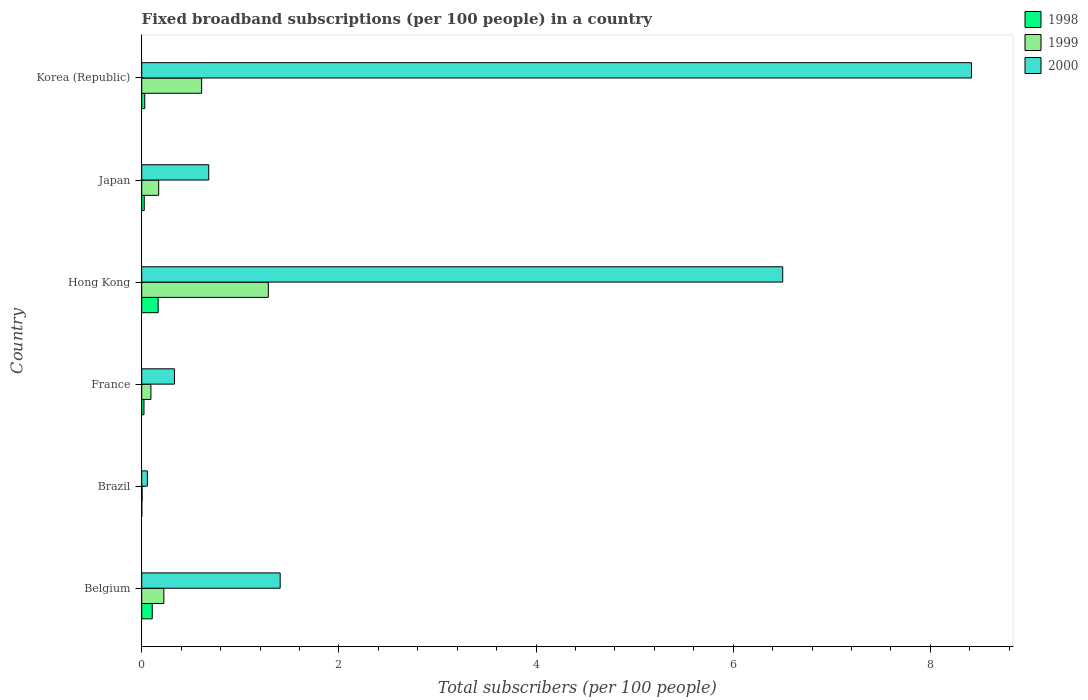How many different coloured bars are there?
Offer a very short reply. 3. How many groups of bars are there?
Offer a very short reply. 6. How many bars are there on the 2nd tick from the top?
Offer a terse response. 3. How many bars are there on the 4th tick from the bottom?
Provide a short and direct response. 3. What is the label of the 5th group of bars from the top?
Offer a very short reply. Brazil. In how many cases, is the number of bars for a given country not equal to the number of legend labels?
Your response must be concise. 0. What is the number of broadband subscriptions in 1999 in France?
Provide a succinct answer. 0.09. Across all countries, what is the maximum number of broadband subscriptions in 2000?
Your response must be concise. 8.42. Across all countries, what is the minimum number of broadband subscriptions in 1999?
Ensure brevity in your answer.  0. In which country was the number of broadband subscriptions in 1998 minimum?
Give a very brief answer. Brazil. What is the total number of broadband subscriptions in 2000 in the graph?
Give a very brief answer. 17.39. What is the difference between the number of broadband subscriptions in 2000 in Hong Kong and that in Japan?
Make the answer very short. 5.82. What is the difference between the number of broadband subscriptions in 2000 in Japan and the number of broadband subscriptions in 1999 in Hong Kong?
Your response must be concise. -0.6. What is the average number of broadband subscriptions in 2000 per country?
Your response must be concise. 2.9. What is the difference between the number of broadband subscriptions in 1999 and number of broadband subscriptions in 1998 in Japan?
Keep it short and to the point. 0.15. What is the ratio of the number of broadband subscriptions in 1999 in Brazil to that in Hong Kong?
Your answer should be very brief. 0. Is the difference between the number of broadband subscriptions in 1999 in Hong Kong and Korea (Republic) greater than the difference between the number of broadband subscriptions in 1998 in Hong Kong and Korea (Republic)?
Your response must be concise. Yes. What is the difference between the highest and the second highest number of broadband subscriptions in 1999?
Offer a terse response. 0.68. What is the difference between the highest and the lowest number of broadband subscriptions in 1998?
Your answer should be compact. 0.17. In how many countries, is the number of broadband subscriptions in 2000 greater than the average number of broadband subscriptions in 2000 taken over all countries?
Offer a very short reply. 2. Is the sum of the number of broadband subscriptions in 1998 in Hong Kong and Japan greater than the maximum number of broadband subscriptions in 1999 across all countries?
Make the answer very short. No. What does the 3rd bar from the top in Hong Kong represents?
Your answer should be very brief. 1998. Is it the case that in every country, the sum of the number of broadband subscriptions in 1998 and number of broadband subscriptions in 1999 is greater than the number of broadband subscriptions in 2000?
Ensure brevity in your answer.  No. How many bars are there?
Give a very brief answer. 18. Are all the bars in the graph horizontal?
Ensure brevity in your answer.  Yes. What is the difference between two consecutive major ticks on the X-axis?
Ensure brevity in your answer.  2. Does the graph contain any zero values?
Give a very brief answer. No. Does the graph contain grids?
Ensure brevity in your answer.  No. Where does the legend appear in the graph?
Your response must be concise. Top right. How many legend labels are there?
Keep it short and to the point. 3. How are the legend labels stacked?
Give a very brief answer. Vertical. What is the title of the graph?
Offer a terse response. Fixed broadband subscriptions (per 100 people) in a country. Does "2013" appear as one of the legend labels in the graph?
Provide a succinct answer. No. What is the label or title of the X-axis?
Provide a short and direct response. Total subscribers (per 100 people). What is the label or title of the Y-axis?
Your answer should be very brief. Country. What is the Total subscribers (per 100 people) of 1998 in Belgium?
Your response must be concise. 0.11. What is the Total subscribers (per 100 people) in 1999 in Belgium?
Keep it short and to the point. 0.22. What is the Total subscribers (per 100 people) of 2000 in Belgium?
Give a very brief answer. 1.4. What is the Total subscribers (per 100 people) in 1998 in Brazil?
Your response must be concise. 0. What is the Total subscribers (per 100 people) in 1999 in Brazil?
Make the answer very short. 0. What is the Total subscribers (per 100 people) of 2000 in Brazil?
Give a very brief answer. 0.06. What is the Total subscribers (per 100 people) of 1998 in France?
Provide a succinct answer. 0.02. What is the Total subscribers (per 100 people) in 1999 in France?
Keep it short and to the point. 0.09. What is the Total subscribers (per 100 people) in 2000 in France?
Offer a very short reply. 0.33. What is the Total subscribers (per 100 people) of 1998 in Hong Kong?
Your answer should be very brief. 0.17. What is the Total subscribers (per 100 people) in 1999 in Hong Kong?
Give a very brief answer. 1.28. What is the Total subscribers (per 100 people) in 2000 in Hong Kong?
Offer a terse response. 6.5. What is the Total subscribers (per 100 people) of 1998 in Japan?
Provide a succinct answer. 0.03. What is the Total subscribers (per 100 people) in 1999 in Japan?
Your answer should be very brief. 0.17. What is the Total subscribers (per 100 people) of 2000 in Japan?
Keep it short and to the point. 0.68. What is the Total subscribers (per 100 people) in 1998 in Korea (Republic)?
Ensure brevity in your answer.  0.03. What is the Total subscribers (per 100 people) in 1999 in Korea (Republic)?
Keep it short and to the point. 0.61. What is the Total subscribers (per 100 people) of 2000 in Korea (Republic)?
Ensure brevity in your answer.  8.42. Across all countries, what is the maximum Total subscribers (per 100 people) of 1998?
Your answer should be very brief. 0.17. Across all countries, what is the maximum Total subscribers (per 100 people) of 1999?
Provide a succinct answer. 1.28. Across all countries, what is the maximum Total subscribers (per 100 people) of 2000?
Offer a very short reply. 8.42. Across all countries, what is the minimum Total subscribers (per 100 people) in 1998?
Offer a very short reply. 0. Across all countries, what is the minimum Total subscribers (per 100 people) of 1999?
Offer a terse response. 0. Across all countries, what is the minimum Total subscribers (per 100 people) in 2000?
Make the answer very short. 0.06. What is the total Total subscribers (per 100 people) of 1998 in the graph?
Provide a succinct answer. 0.35. What is the total Total subscribers (per 100 people) in 1999 in the graph?
Offer a very short reply. 2.39. What is the total Total subscribers (per 100 people) of 2000 in the graph?
Provide a succinct answer. 17.39. What is the difference between the Total subscribers (per 100 people) in 1998 in Belgium and that in Brazil?
Make the answer very short. 0.11. What is the difference between the Total subscribers (per 100 people) in 1999 in Belgium and that in Brazil?
Keep it short and to the point. 0.22. What is the difference between the Total subscribers (per 100 people) in 2000 in Belgium and that in Brazil?
Keep it short and to the point. 1.35. What is the difference between the Total subscribers (per 100 people) of 1998 in Belgium and that in France?
Make the answer very short. 0.08. What is the difference between the Total subscribers (per 100 people) in 1999 in Belgium and that in France?
Your answer should be compact. 0.13. What is the difference between the Total subscribers (per 100 people) of 2000 in Belgium and that in France?
Your response must be concise. 1.07. What is the difference between the Total subscribers (per 100 people) of 1998 in Belgium and that in Hong Kong?
Keep it short and to the point. -0.06. What is the difference between the Total subscribers (per 100 people) in 1999 in Belgium and that in Hong Kong?
Offer a terse response. -1.06. What is the difference between the Total subscribers (per 100 people) of 2000 in Belgium and that in Hong Kong?
Your answer should be compact. -5.1. What is the difference between the Total subscribers (per 100 people) of 1998 in Belgium and that in Japan?
Provide a short and direct response. 0.08. What is the difference between the Total subscribers (per 100 people) in 1999 in Belgium and that in Japan?
Make the answer very short. 0.05. What is the difference between the Total subscribers (per 100 people) in 2000 in Belgium and that in Japan?
Give a very brief answer. 0.72. What is the difference between the Total subscribers (per 100 people) in 1998 in Belgium and that in Korea (Republic)?
Your response must be concise. 0.08. What is the difference between the Total subscribers (per 100 people) in 1999 in Belgium and that in Korea (Republic)?
Offer a terse response. -0.38. What is the difference between the Total subscribers (per 100 people) in 2000 in Belgium and that in Korea (Republic)?
Provide a succinct answer. -7.01. What is the difference between the Total subscribers (per 100 people) in 1998 in Brazil and that in France?
Give a very brief answer. -0.02. What is the difference between the Total subscribers (per 100 people) of 1999 in Brazil and that in France?
Give a very brief answer. -0.09. What is the difference between the Total subscribers (per 100 people) in 2000 in Brazil and that in France?
Provide a succinct answer. -0.27. What is the difference between the Total subscribers (per 100 people) of 1998 in Brazil and that in Hong Kong?
Provide a succinct answer. -0.17. What is the difference between the Total subscribers (per 100 people) in 1999 in Brazil and that in Hong Kong?
Keep it short and to the point. -1.28. What is the difference between the Total subscribers (per 100 people) of 2000 in Brazil and that in Hong Kong?
Keep it short and to the point. -6.45. What is the difference between the Total subscribers (per 100 people) in 1998 in Brazil and that in Japan?
Provide a short and direct response. -0.03. What is the difference between the Total subscribers (per 100 people) in 1999 in Brazil and that in Japan?
Your answer should be compact. -0.17. What is the difference between the Total subscribers (per 100 people) of 2000 in Brazil and that in Japan?
Provide a succinct answer. -0.62. What is the difference between the Total subscribers (per 100 people) in 1998 in Brazil and that in Korea (Republic)?
Provide a succinct answer. -0.03. What is the difference between the Total subscribers (per 100 people) in 1999 in Brazil and that in Korea (Republic)?
Offer a terse response. -0.6. What is the difference between the Total subscribers (per 100 people) of 2000 in Brazil and that in Korea (Republic)?
Offer a very short reply. -8.36. What is the difference between the Total subscribers (per 100 people) in 1998 in France and that in Hong Kong?
Keep it short and to the point. -0.14. What is the difference between the Total subscribers (per 100 people) of 1999 in France and that in Hong Kong?
Your answer should be compact. -1.19. What is the difference between the Total subscribers (per 100 people) in 2000 in France and that in Hong Kong?
Your response must be concise. -6.17. What is the difference between the Total subscribers (per 100 people) in 1998 in France and that in Japan?
Provide a short and direct response. -0. What is the difference between the Total subscribers (per 100 people) of 1999 in France and that in Japan?
Your answer should be compact. -0.08. What is the difference between the Total subscribers (per 100 people) in 2000 in France and that in Japan?
Make the answer very short. -0.35. What is the difference between the Total subscribers (per 100 people) of 1998 in France and that in Korea (Republic)?
Offer a very short reply. -0.01. What is the difference between the Total subscribers (per 100 people) of 1999 in France and that in Korea (Republic)?
Offer a terse response. -0.51. What is the difference between the Total subscribers (per 100 people) of 2000 in France and that in Korea (Republic)?
Offer a very short reply. -8.09. What is the difference between the Total subscribers (per 100 people) in 1998 in Hong Kong and that in Japan?
Offer a very short reply. 0.14. What is the difference between the Total subscribers (per 100 people) in 1999 in Hong Kong and that in Japan?
Keep it short and to the point. 1.11. What is the difference between the Total subscribers (per 100 people) of 2000 in Hong Kong and that in Japan?
Provide a succinct answer. 5.82. What is the difference between the Total subscribers (per 100 people) in 1998 in Hong Kong and that in Korea (Republic)?
Make the answer very short. 0.14. What is the difference between the Total subscribers (per 100 people) of 1999 in Hong Kong and that in Korea (Republic)?
Offer a very short reply. 0.68. What is the difference between the Total subscribers (per 100 people) in 2000 in Hong Kong and that in Korea (Republic)?
Provide a succinct answer. -1.91. What is the difference between the Total subscribers (per 100 people) in 1998 in Japan and that in Korea (Republic)?
Offer a terse response. -0.01. What is the difference between the Total subscribers (per 100 people) of 1999 in Japan and that in Korea (Republic)?
Your answer should be very brief. -0.44. What is the difference between the Total subscribers (per 100 people) of 2000 in Japan and that in Korea (Republic)?
Your answer should be compact. -7.74. What is the difference between the Total subscribers (per 100 people) of 1998 in Belgium and the Total subscribers (per 100 people) of 1999 in Brazil?
Provide a succinct answer. 0.1. What is the difference between the Total subscribers (per 100 people) of 1998 in Belgium and the Total subscribers (per 100 people) of 2000 in Brazil?
Your response must be concise. 0.05. What is the difference between the Total subscribers (per 100 people) in 1999 in Belgium and the Total subscribers (per 100 people) in 2000 in Brazil?
Give a very brief answer. 0.17. What is the difference between the Total subscribers (per 100 people) of 1998 in Belgium and the Total subscribers (per 100 people) of 1999 in France?
Provide a succinct answer. 0.01. What is the difference between the Total subscribers (per 100 people) in 1998 in Belgium and the Total subscribers (per 100 people) in 2000 in France?
Your answer should be compact. -0.23. What is the difference between the Total subscribers (per 100 people) in 1999 in Belgium and the Total subscribers (per 100 people) in 2000 in France?
Your answer should be very brief. -0.11. What is the difference between the Total subscribers (per 100 people) of 1998 in Belgium and the Total subscribers (per 100 people) of 1999 in Hong Kong?
Give a very brief answer. -1.18. What is the difference between the Total subscribers (per 100 people) of 1998 in Belgium and the Total subscribers (per 100 people) of 2000 in Hong Kong?
Give a very brief answer. -6.4. What is the difference between the Total subscribers (per 100 people) in 1999 in Belgium and the Total subscribers (per 100 people) in 2000 in Hong Kong?
Make the answer very short. -6.28. What is the difference between the Total subscribers (per 100 people) in 1998 in Belgium and the Total subscribers (per 100 people) in 1999 in Japan?
Offer a very short reply. -0.07. What is the difference between the Total subscribers (per 100 people) in 1998 in Belgium and the Total subscribers (per 100 people) in 2000 in Japan?
Offer a very short reply. -0.57. What is the difference between the Total subscribers (per 100 people) in 1999 in Belgium and the Total subscribers (per 100 people) in 2000 in Japan?
Offer a very short reply. -0.46. What is the difference between the Total subscribers (per 100 people) of 1998 in Belgium and the Total subscribers (per 100 people) of 1999 in Korea (Republic)?
Offer a very short reply. -0.5. What is the difference between the Total subscribers (per 100 people) in 1998 in Belgium and the Total subscribers (per 100 people) in 2000 in Korea (Republic)?
Provide a short and direct response. -8.31. What is the difference between the Total subscribers (per 100 people) in 1999 in Belgium and the Total subscribers (per 100 people) in 2000 in Korea (Republic)?
Your response must be concise. -8.19. What is the difference between the Total subscribers (per 100 people) of 1998 in Brazil and the Total subscribers (per 100 people) of 1999 in France?
Offer a terse response. -0.09. What is the difference between the Total subscribers (per 100 people) of 1998 in Brazil and the Total subscribers (per 100 people) of 2000 in France?
Provide a short and direct response. -0.33. What is the difference between the Total subscribers (per 100 people) in 1999 in Brazil and the Total subscribers (per 100 people) in 2000 in France?
Provide a short and direct response. -0.33. What is the difference between the Total subscribers (per 100 people) in 1998 in Brazil and the Total subscribers (per 100 people) in 1999 in Hong Kong?
Offer a very short reply. -1.28. What is the difference between the Total subscribers (per 100 people) in 1998 in Brazil and the Total subscribers (per 100 people) in 2000 in Hong Kong?
Your response must be concise. -6.5. What is the difference between the Total subscribers (per 100 people) of 1999 in Brazil and the Total subscribers (per 100 people) of 2000 in Hong Kong?
Your answer should be very brief. -6.5. What is the difference between the Total subscribers (per 100 people) of 1998 in Brazil and the Total subscribers (per 100 people) of 1999 in Japan?
Keep it short and to the point. -0.17. What is the difference between the Total subscribers (per 100 people) in 1998 in Brazil and the Total subscribers (per 100 people) in 2000 in Japan?
Your answer should be compact. -0.68. What is the difference between the Total subscribers (per 100 people) in 1999 in Brazil and the Total subscribers (per 100 people) in 2000 in Japan?
Your answer should be very brief. -0.68. What is the difference between the Total subscribers (per 100 people) in 1998 in Brazil and the Total subscribers (per 100 people) in 1999 in Korea (Republic)?
Make the answer very short. -0.61. What is the difference between the Total subscribers (per 100 people) of 1998 in Brazil and the Total subscribers (per 100 people) of 2000 in Korea (Republic)?
Your response must be concise. -8.42. What is the difference between the Total subscribers (per 100 people) in 1999 in Brazil and the Total subscribers (per 100 people) in 2000 in Korea (Republic)?
Your response must be concise. -8.41. What is the difference between the Total subscribers (per 100 people) in 1998 in France and the Total subscribers (per 100 people) in 1999 in Hong Kong?
Provide a short and direct response. -1.26. What is the difference between the Total subscribers (per 100 people) of 1998 in France and the Total subscribers (per 100 people) of 2000 in Hong Kong?
Offer a very short reply. -6.48. What is the difference between the Total subscribers (per 100 people) of 1999 in France and the Total subscribers (per 100 people) of 2000 in Hong Kong?
Keep it short and to the point. -6.41. What is the difference between the Total subscribers (per 100 people) in 1998 in France and the Total subscribers (per 100 people) in 1999 in Japan?
Your response must be concise. -0.15. What is the difference between the Total subscribers (per 100 people) in 1998 in France and the Total subscribers (per 100 people) in 2000 in Japan?
Provide a short and direct response. -0.66. What is the difference between the Total subscribers (per 100 people) in 1999 in France and the Total subscribers (per 100 people) in 2000 in Japan?
Keep it short and to the point. -0.59. What is the difference between the Total subscribers (per 100 people) in 1998 in France and the Total subscribers (per 100 people) in 1999 in Korea (Republic)?
Your answer should be compact. -0.58. What is the difference between the Total subscribers (per 100 people) in 1998 in France and the Total subscribers (per 100 people) in 2000 in Korea (Republic)?
Offer a terse response. -8.39. What is the difference between the Total subscribers (per 100 people) of 1999 in France and the Total subscribers (per 100 people) of 2000 in Korea (Republic)?
Provide a short and direct response. -8.32. What is the difference between the Total subscribers (per 100 people) of 1998 in Hong Kong and the Total subscribers (per 100 people) of 1999 in Japan?
Keep it short and to the point. -0.01. What is the difference between the Total subscribers (per 100 people) of 1998 in Hong Kong and the Total subscribers (per 100 people) of 2000 in Japan?
Your response must be concise. -0.51. What is the difference between the Total subscribers (per 100 people) of 1999 in Hong Kong and the Total subscribers (per 100 people) of 2000 in Japan?
Your response must be concise. 0.6. What is the difference between the Total subscribers (per 100 people) of 1998 in Hong Kong and the Total subscribers (per 100 people) of 1999 in Korea (Republic)?
Provide a succinct answer. -0.44. What is the difference between the Total subscribers (per 100 people) of 1998 in Hong Kong and the Total subscribers (per 100 people) of 2000 in Korea (Republic)?
Give a very brief answer. -8.25. What is the difference between the Total subscribers (per 100 people) of 1999 in Hong Kong and the Total subscribers (per 100 people) of 2000 in Korea (Republic)?
Offer a terse response. -7.13. What is the difference between the Total subscribers (per 100 people) of 1998 in Japan and the Total subscribers (per 100 people) of 1999 in Korea (Republic)?
Provide a succinct answer. -0.58. What is the difference between the Total subscribers (per 100 people) in 1998 in Japan and the Total subscribers (per 100 people) in 2000 in Korea (Republic)?
Your answer should be very brief. -8.39. What is the difference between the Total subscribers (per 100 people) in 1999 in Japan and the Total subscribers (per 100 people) in 2000 in Korea (Republic)?
Provide a succinct answer. -8.25. What is the average Total subscribers (per 100 people) of 1998 per country?
Your answer should be very brief. 0.06. What is the average Total subscribers (per 100 people) in 1999 per country?
Offer a terse response. 0.4. What is the average Total subscribers (per 100 people) in 2000 per country?
Offer a terse response. 2.9. What is the difference between the Total subscribers (per 100 people) in 1998 and Total subscribers (per 100 people) in 1999 in Belgium?
Your response must be concise. -0.12. What is the difference between the Total subscribers (per 100 people) in 1998 and Total subscribers (per 100 people) in 2000 in Belgium?
Keep it short and to the point. -1.3. What is the difference between the Total subscribers (per 100 people) of 1999 and Total subscribers (per 100 people) of 2000 in Belgium?
Offer a terse response. -1.18. What is the difference between the Total subscribers (per 100 people) of 1998 and Total subscribers (per 100 people) of 1999 in Brazil?
Keep it short and to the point. -0. What is the difference between the Total subscribers (per 100 people) in 1998 and Total subscribers (per 100 people) in 2000 in Brazil?
Offer a very short reply. -0.06. What is the difference between the Total subscribers (per 100 people) in 1999 and Total subscribers (per 100 people) in 2000 in Brazil?
Ensure brevity in your answer.  -0.05. What is the difference between the Total subscribers (per 100 people) in 1998 and Total subscribers (per 100 people) in 1999 in France?
Your response must be concise. -0.07. What is the difference between the Total subscribers (per 100 people) of 1998 and Total subscribers (per 100 people) of 2000 in France?
Give a very brief answer. -0.31. What is the difference between the Total subscribers (per 100 people) of 1999 and Total subscribers (per 100 people) of 2000 in France?
Make the answer very short. -0.24. What is the difference between the Total subscribers (per 100 people) in 1998 and Total subscribers (per 100 people) in 1999 in Hong Kong?
Make the answer very short. -1.12. What is the difference between the Total subscribers (per 100 people) in 1998 and Total subscribers (per 100 people) in 2000 in Hong Kong?
Offer a terse response. -6.34. What is the difference between the Total subscribers (per 100 people) of 1999 and Total subscribers (per 100 people) of 2000 in Hong Kong?
Your answer should be very brief. -5.22. What is the difference between the Total subscribers (per 100 people) in 1998 and Total subscribers (per 100 people) in 1999 in Japan?
Make the answer very short. -0.15. What is the difference between the Total subscribers (per 100 people) of 1998 and Total subscribers (per 100 people) of 2000 in Japan?
Your answer should be very brief. -0.65. What is the difference between the Total subscribers (per 100 people) of 1999 and Total subscribers (per 100 people) of 2000 in Japan?
Keep it short and to the point. -0.51. What is the difference between the Total subscribers (per 100 people) of 1998 and Total subscribers (per 100 people) of 1999 in Korea (Republic)?
Keep it short and to the point. -0.58. What is the difference between the Total subscribers (per 100 people) in 1998 and Total subscribers (per 100 people) in 2000 in Korea (Republic)?
Your answer should be compact. -8.39. What is the difference between the Total subscribers (per 100 people) in 1999 and Total subscribers (per 100 people) in 2000 in Korea (Republic)?
Provide a succinct answer. -7.81. What is the ratio of the Total subscribers (per 100 people) of 1998 in Belgium to that in Brazil?
Your answer should be compact. 181.1. What is the ratio of the Total subscribers (per 100 people) of 1999 in Belgium to that in Brazil?
Ensure brevity in your answer.  55.18. What is the ratio of the Total subscribers (per 100 people) in 2000 in Belgium to that in Brazil?
Give a very brief answer. 24.51. What is the ratio of the Total subscribers (per 100 people) of 1998 in Belgium to that in France?
Provide a succinct answer. 4.65. What is the ratio of the Total subscribers (per 100 people) of 1999 in Belgium to that in France?
Your answer should be compact. 2.4. What is the ratio of the Total subscribers (per 100 people) of 2000 in Belgium to that in France?
Give a very brief answer. 4.23. What is the ratio of the Total subscribers (per 100 people) of 1998 in Belgium to that in Hong Kong?
Offer a terse response. 0.64. What is the ratio of the Total subscribers (per 100 people) of 1999 in Belgium to that in Hong Kong?
Keep it short and to the point. 0.17. What is the ratio of the Total subscribers (per 100 people) of 2000 in Belgium to that in Hong Kong?
Your answer should be compact. 0.22. What is the ratio of the Total subscribers (per 100 people) in 1998 in Belgium to that in Japan?
Give a very brief answer. 4.18. What is the ratio of the Total subscribers (per 100 people) of 1999 in Belgium to that in Japan?
Keep it short and to the point. 1.3. What is the ratio of the Total subscribers (per 100 people) of 2000 in Belgium to that in Japan?
Ensure brevity in your answer.  2.07. What is the ratio of the Total subscribers (per 100 people) of 1998 in Belgium to that in Korea (Republic)?
Ensure brevity in your answer.  3.47. What is the ratio of the Total subscribers (per 100 people) in 1999 in Belgium to that in Korea (Republic)?
Ensure brevity in your answer.  0.37. What is the ratio of the Total subscribers (per 100 people) of 2000 in Belgium to that in Korea (Republic)?
Ensure brevity in your answer.  0.17. What is the ratio of the Total subscribers (per 100 people) in 1998 in Brazil to that in France?
Provide a succinct answer. 0.03. What is the ratio of the Total subscribers (per 100 people) in 1999 in Brazil to that in France?
Make the answer very short. 0.04. What is the ratio of the Total subscribers (per 100 people) in 2000 in Brazil to that in France?
Offer a terse response. 0.17. What is the ratio of the Total subscribers (per 100 people) in 1998 in Brazil to that in Hong Kong?
Ensure brevity in your answer.  0. What is the ratio of the Total subscribers (per 100 people) of 1999 in Brazil to that in Hong Kong?
Make the answer very short. 0. What is the ratio of the Total subscribers (per 100 people) of 2000 in Brazil to that in Hong Kong?
Give a very brief answer. 0.01. What is the ratio of the Total subscribers (per 100 people) of 1998 in Brazil to that in Japan?
Ensure brevity in your answer.  0.02. What is the ratio of the Total subscribers (per 100 people) in 1999 in Brazil to that in Japan?
Offer a terse response. 0.02. What is the ratio of the Total subscribers (per 100 people) in 2000 in Brazil to that in Japan?
Make the answer very short. 0.08. What is the ratio of the Total subscribers (per 100 people) of 1998 in Brazil to that in Korea (Republic)?
Give a very brief answer. 0.02. What is the ratio of the Total subscribers (per 100 people) of 1999 in Brazil to that in Korea (Republic)?
Your response must be concise. 0.01. What is the ratio of the Total subscribers (per 100 people) of 2000 in Brazil to that in Korea (Republic)?
Make the answer very short. 0.01. What is the ratio of the Total subscribers (per 100 people) in 1998 in France to that in Hong Kong?
Provide a short and direct response. 0.14. What is the ratio of the Total subscribers (per 100 people) of 1999 in France to that in Hong Kong?
Provide a succinct answer. 0.07. What is the ratio of the Total subscribers (per 100 people) of 2000 in France to that in Hong Kong?
Your answer should be compact. 0.05. What is the ratio of the Total subscribers (per 100 people) in 1998 in France to that in Japan?
Your answer should be very brief. 0.9. What is the ratio of the Total subscribers (per 100 people) in 1999 in France to that in Japan?
Offer a terse response. 0.54. What is the ratio of the Total subscribers (per 100 people) in 2000 in France to that in Japan?
Your answer should be compact. 0.49. What is the ratio of the Total subscribers (per 100 people) in 1998 in France to that in Korea (Republic)?
Make the answer very short. 0.75. What is the ratio of the Total subscribers (per 100 people) of 1999 in France to that in Korea (Republic)?
Your answer should be compact. 0.15. What is the ratio of the Total subscribers (per 100 people) in 2000 in France to that in Korea (Republic)?
Your response must be concise. 0.04. What is the ratio of the Total subscribers (per 100 people) of 1998 in Hong Kong to that in Japan?
Make the answer very short. 6.53. What is the ratio of the Total subscribers (per 100 people) in 1999 in Hong Kong to that in Japan?
Offer a very short reply. 7.46. What is the ratio of the Total subscribers (per 100 people) in 2000 in Hong Kong to that in Japan?
Keep it short and to the point. 9.56. What is the ratio of the Total subscribers (per 100 people) in 1998 in Hong Kong to that in Korea (Republic)?
Ensure brevity in your answer.  5.42. What is the ratio of the Total subscribers (per 100 people) in 1999 in Hong Kong to that in Korea (Republic)?
Offer a terse response. 2.11. What is the ratio of the Total subscribers (per 100 people) of 2000 in Hong Kong to that in Korea (Republic)?
Keep it short and to the point. 0.77. What is the ratio of the Total subscribers (per 100 people) of 1998 in Japan to that in Korea (Republic)?
Offer a very short reply. 0.83. What is the ratio of the Total subscribers (per 100 people) of 1999 in Japan to that in Korea (Republic)?
Make the answer very short. 0.28. What is the ratio of the Total subscribers (per 100 people) in 2000 in Japan to that in Korea (Republic)?
Ensure brevity in your answer.  0.08. What is the difference between the highest and the second highest Total subscribers (per 100 people) in 1999?
Provide a short and direct response. 0.68. What is the difference between the highest and the second highest Total subscribers (per 100 people) of 2000?
Your answer should be compact. 1.91. What is the difference between the highest and the lowest Total subscribers (per 100 people) in 1998?
Offer a very short reply. 0.17. What is the difference between the highest and the lowest Total subscribers (per 100 people) in 1999?
Your answer should be compact. 1.28. What is the difference between the highest and the lowest Total subscribers (per 100 people) of 2000?
Give a very brief answer. 8.36. 